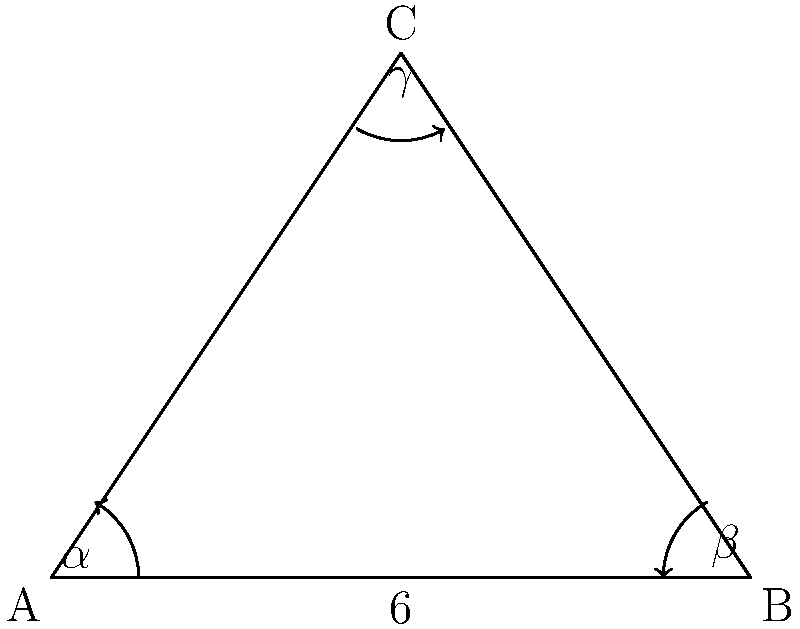In managing lupus, consider three aspects of care: medication (side A), lifestyle changes (side B), and emotional support (side C). These form a triangle where side A is 6 units long, angle $\alpha$ (opposite side a) is 30°, and angle $\beta$ (opposite side b) is 45°. Using the law of sines, calculate the length of side C, representing the importance of emotional support in your lupus management plan. Let's approach this step-by-step using the law of sines:

1) The law of sines states: $\frac{a}{\sin A} = \frac{b}{\sin B} = \frac{c}{\sin C}$

2) We know:
   - Side $a = 6$
   - Angle $\alpha = 30°$
   - Angle $\beta = 45°$

3) We can find angle $\gamma$ using the fact that angles in a triangle sum to 180°:
   $\gamma = 180° - (30° + 45°) = 105°$

4) Now we can use the law of sines to find side $c$:
   $\frac{6}{\sin 30°} = \frac{c}{\sin 105°}$

5) Cross multiply:
   $6 \cdot \sin 105° = c \cdot \sin 30°$

6) Solve for $c$:
   $c = \frac{6 \cdot \sin 105°}{\sin 30°}$

7) Calculate:
   $c = \frac{6 \cdot 0.9659}{0.5} \approx 11.59$

Thus, the length of side C, representing emotional support, is approximately 11.59 units.
Answer: 11.59 units 